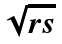<formula> <loc_0><loc_0><loc_500><loc_500>\sqrt { r s }</formula> 